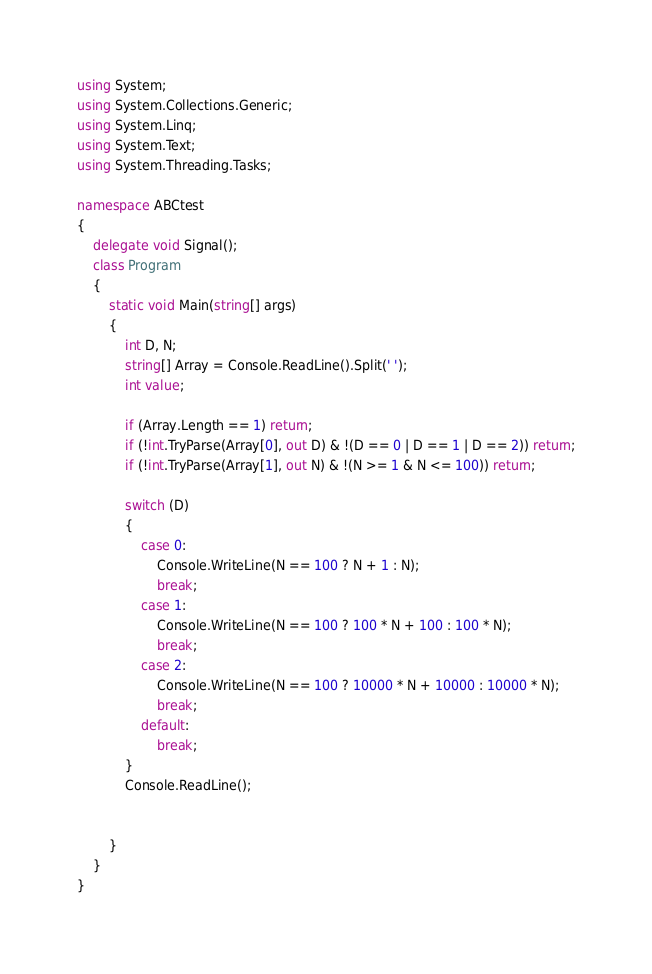Convert code to text. <code><loc_0><loc_0><loc_500><loc_500><_C#_>using System;
using System.Collections.Generic;
using System.Linq;
using System.Text;
using System.Threading.Tasks;

namespace ABCtest
{
    delegate void Signal();
    class Program
    {
        static void Main(string[] args)
        {
            int D, N;
            string[] Array = Console.ReadLine().Split(' ');
            int value;

            if (Array.Length == 1) return;
            if (!int.TryParse(Array[0], out D) & !(D == 0 | D == 1 | D == 2)) return;
            if (!int.TryParse(Array[1], out N) & !(N >= 1 & N <= 100)) return;

            switch (D)
            {
                case 0:
                    Console.WriteLine(N == 100 ? N + 1 : N);
                    break;
                case 1:
                    Console.WriteLine(N == 100 ? 100 * N + 100 : 100 * N);
                    break;
                case 2:
                    Console.WriteLine(N == 100 ? 10000 * N + 10000 : 10000 * N);
                    break;
                default:
                    break;
            }
            Console.ReadLine();


        }
    }
}</code> 